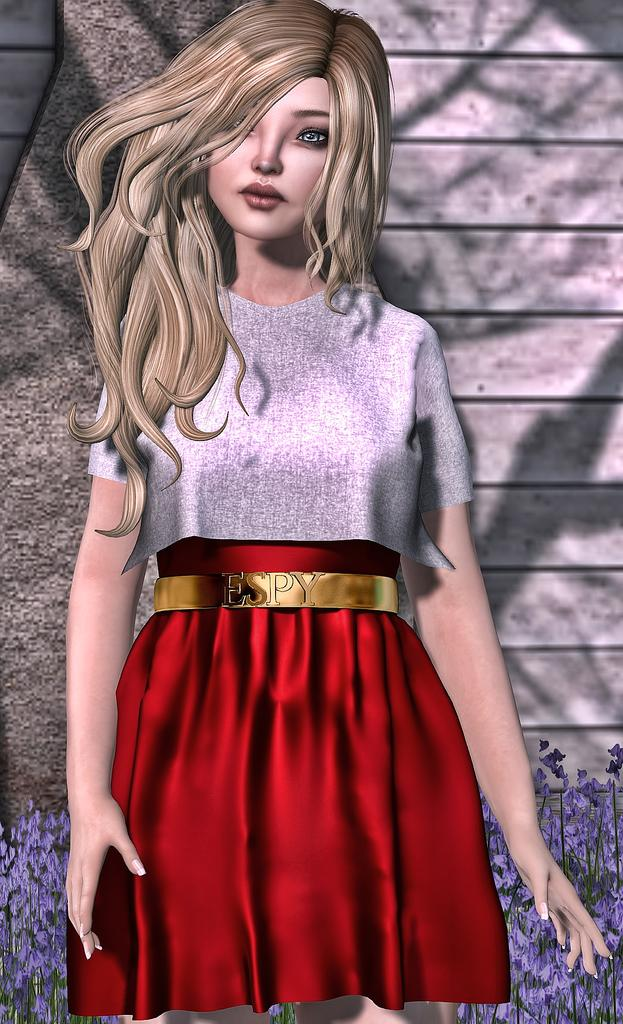What is the main subject in the center of the image? There is a barbie doll in the center of the image. What can be seen in the background of the image? There are flowers and a wall in the background of the image. What type of base is supporting the barbie doll in the image? There is no base visible in the image; the barbie doll is likely standing on its own or on a surface that is not visible in the image. 